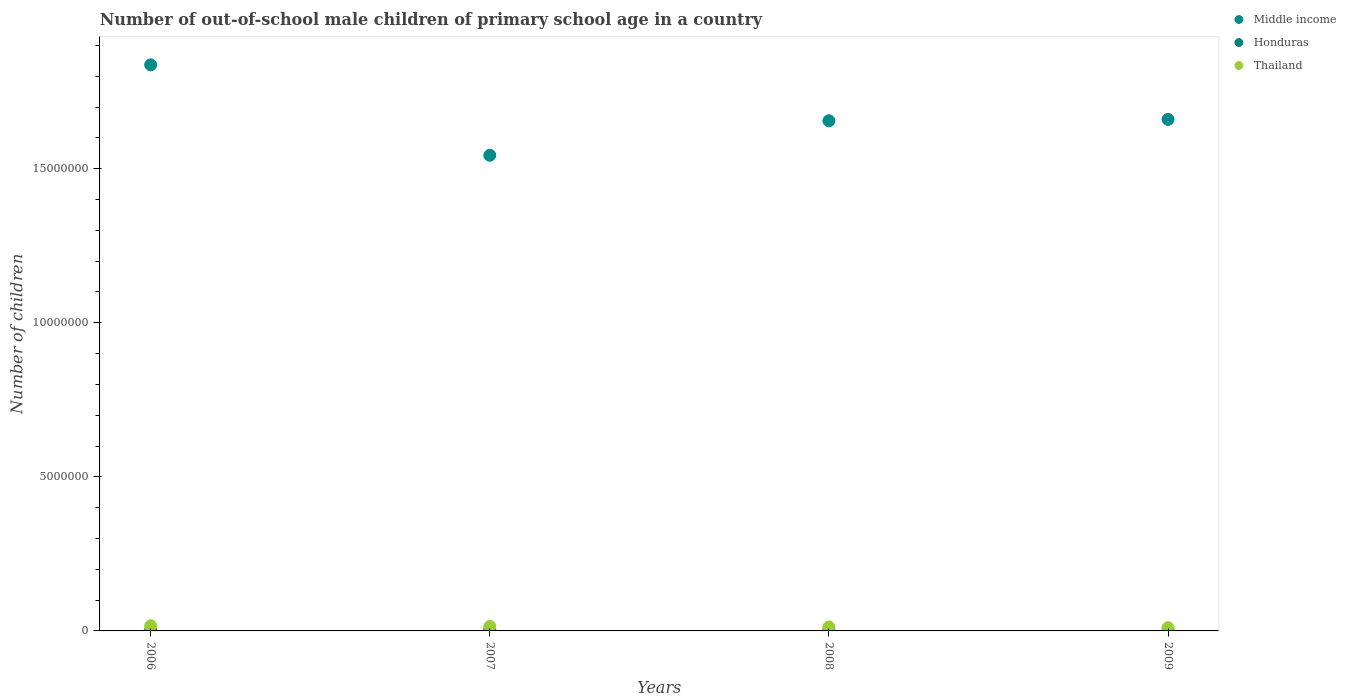What is the number of out-of-school male children in Middle income in 2006?
Give a very brief answer. 1.84e+07. Across all years, what is the maximum number of out-of-school male children in Honduras?
Keep it short and to the point. 4.40e+04. Across all years, what is the minimum number of out-of-school male children in Honduras?
Provide a short and direct response. 2.52e+04. In which year was the number of out-of-school male children in Honduras minimum?
Keep it short and to the point. 2009. What is the total number of out-of-school male children in Middle income in the graph?
Your response must be concise. 6.70e+07. What is the difference between the number of out-of-school male children in Middle income in 2008 and that in 2009?
Provide a succinct answer. -4.42e+04. What is the difference between the number of out-of-school male children in Honduras in 2006 and the number of out-of-school male children in Middle income in 2007?
Give a very brief answer. -1.54e+07. What is the average number of out-of-school male children in Honduras per year?
Keep it short and to the point. 3.06e+04. In the year 2008, what is the difference between the number of out-of-school male children in Honduras and number of out-of-school male children in Thailand?
Your answer should be compact. -1.01e+05. What is the ratio of the number of out-of-school male children in Middle income in 2006 to that in 2007?
Your answer should be compact. 1.19. Is the difference between the number of out-of-school male children in Honduras in 2007 and 2008 greater than the difference between the number of out-of-school male children in Thailand in 2007 and 2008?
Ensure brevity in your answer.  No. What is the difference between the highest and the second highest number of out-of-school male children in Honduras?
Ensure brevity in your answer.  1.67e+04. What is the difference between the highest and the lowest number of out-of-school male children in Honduras?
Your answer should be very brief. 1.87e+04. In how many years, is the number of out-of-school male children in Thailand greater than the average number of out-of-school male children in Thailand taken over all years?
Provide a short and direct response. 2. Is the sum of the number of out-of-school male children in Middle income in 2006 and 2009 greater than the maximum number of out-of-school male children in Thailand across all years?
Make the answer very short. Yes. Is the number of out-of-school male children in Honduras strictly greater than the number of out-of-school male children in Thailand over the years?
Keep it short and to the point. No. How many dotlines are there?
Give a very brief answer. 3. Does the graph contain any zero values?
Give a very brief answer. No. Does the graph contain grids?
Give a very brief answer. No. Where does the legend appear in the graph?
Your answer should be compact. Top right. How many legend labels are there?
Your answer should be very brief. 3. What is the title of the graph?
Ensure brevity in your answer.  Number of out-of-school male children of primary school age in a country. Does "Madagascar" appear as one of the legend labels in the graph?
Offer a very short reply. No. What is the label or title of the X-axis?
Give a very brief answer. Years. What is the label or title of the Y-axis?
Offer a very short reply. Number of children. What is the Number of children of Middle income in 2006?
Keep it short and to the point. 1.84e+07. What is the Number of children in Honduras in 2006?
Keep it short and to the point. 2.59e+04. What is the Number of children of Thailand in 2006?
Your answer should be compact. 1.67e+05. What is the Number of children in Middle income in 2007?
Provide a succinct answer. 1.54e+07. What is the Number of children in Honduras in 2007?
Keep it short and to the point. 4.40e+04. What is the Number of children in Thailand in 2007?
Your answer should be very brief. 1.47e+05. What is the Number of children in Middle income in 2008?
Make the answer very short. 1.66e+07. What is the Number of children in Honduras in 2008?
Your response must be concise. 2.73e+04. What is the Number of children in Thailand in 2008?
Your response must be concise. 1.29e+05. What is the Number of children in Middle income in 2009?
Provide a succinct answer. 1.66e+07. What is the Number of children of Honduras in 2009?
Provide a short and direct response. 2.52e+04. What is the Number of children of Thailand in 2009?
Your answer should be compact. 1.07e+05. Across all years, what is the maximum Number of children in Middle income?
Ensure brevity in your answer.  1.84e+07. Across all years, what is the maximum Number of children of Honduras?
Make the answer very short. 4.40e+04. Across all years, what is the maximum Number of children of Thailand?
Provide a short and direct response. 1.67e+05. Across all years, what is the minimum Number of children of Middle income?
Provide a short and direct response. 1.54e+07. Across all years, what is the minimum Number of children in Honduras?
Offer a terse response. 2.52e+04. Across all years, what is the minimum Number of children in Thailand?
Your response must be concise. 1.07e+05. What is the total Number of children in Middle income in the graph?
Offer a very short reply. 6.70e+07. What is the total Number of children of Honduras in the graph?
Your response must be concise. 1.22e+05. What is the total Number of children in Thailand in the graph?
Keep it short and to the point. 5.50e+05. What is the difference between the Number of children in Middle income in 2006 and that in 2007?
Make the answer very short. 2.94e+06. What is the difference between the Number of children in Honduras in 2006 and that in 2007?
Provide a succinct answer. -1.81e+04. What is the difference between the Number of children of Thailand in 2006 and that in 2007?
Keep it short and to the point. 2.01e+04. What is the difference between the Number of children in Middle income in 2006 and that in 2008?
Provide a succinct answer. 1.82e+06. What is the difference between the Number of children of Honduras in 2006 and that in 2008?
Provide a succinct answer. -1472. What is the difference between the Number of children of Thailand in 2006 and that in 2008?
Provide a succinct answer. 3.86e+04. What is the difference between the Number of children of Middle income in 2006 and that in 2009?
Give a very brief answer. 1.77e+06. What is the difference between the Number of children in Honduras in 2006 and that in 2009?
Provide a short and direct response. 610. What is the difference between the Number of children of Thailand in 2006 and that in 2009?
Your response must be concise. 6.07e+04. What is the difference between the Number of children of Middle income in 2007 and that in 2008?
Your answer should be compact. -1.12e+06. What is the difference between the Number of children in Honduras in 2007 and that in 2008?
Offer a very short reply. 1.67e+04. What is the difference between the Number of children in Thailand in 2007 and that in 2008?
Offer a very short reply. 1.85e+04. What is the difference between the Number of children in Middle income in 2007 and that in 2009?
Your answer should be compact. -1.16e+06. What is the difference between the Number of children in Honduras in 2007 and that in 2009?
Provide a succinct answer. 1.87e+04. What is the difference between the Number of children in Thailand in 2007 and that in 2009?
Your answer should be compact. 4.06e+04. What is the difference between the Number of children of Middle income in 2008 and that in 2009?
Give a very brief answer. -4.42e+04. What is the difference between the Number of children of Honduras in 2008 and that in 2009?
Keep it short and to the point. 2082. What is the difference between the Number of children in Thailand in 2008 and that in 2009?
Give a very brief answer. 2.21e+04. What is the difference between the Number of children in Middle income in 2006 and the Number of children in Honduras in 2007?
Your response must be concise. 1.83e+07. What is the difference between the Number of children of Middle income in 2006 and the Number of children of Thailand in 2007?
Your answer should be compact. 1.82e+07. What is the difference between the Number of children of Honduras in 2006 and the Number of children of Thailand in 2007?
Your answer should be very brief. -1.21e+05. What is the difference between the Number of children in Middle income in 2006 and the Number of children in Honduras in 2008?
Keep it short and to the point. 1.83e+07. What is the difference between the Number of children in Middle income in 2006 and the Number of children in Thailand in 2008?
Ensure brevity in your answer.  1.82e+07. What is the difference between the Number of children in Honduras in 2006 and the Number of children in Thailand in 2008?
Keep it short and to the point. -1.03e+05. What is the difference between the Number of children of Middle income in 2006 and the Number of children of Honduras in 2009?
Give a very brief answer. 1.83e+07. What is the difference between the Number of children in Middle income in 2006 and the Number of children in Thailand in 2009?
Provide a short and direct response. 1.83e+07. What is the difference between the Number of children in Honduras in 2006 and the Number of children in Thailand in 2009?
Provide a succinct answer. -8.07e+04. What is the difference between the Number of children in Middle income in 2007 and the Number of children in Honduras in 2008?
Provide a short and direct response. 1.54e+07. What is the difference between the Number of children in Middle income in 2007 and the Number of children in Thailand in 2008?
Your answer should be compact. 1.53e+07. What is the difference between the Number of children of Honduras in 2007 and the Number of children of Thailand in 2008?
Offer a terse response. -8.46e+04. What is the difference between the Number of children in Middle income in 2007 and the Number of children in Honduras in 2009?
Your answer should be very brief. 1.54e+07. What is the difference between the Number of children of Middle income in 2007 and the Number of children of Thailand in 2009?
Keep it short and to the point. 1.53e+07. What is the difference between the Number of children in Honduras in 2007 and the Number of children in Thailand in 2009?
Your response must be concise. -6.26e+04. What is the difference between the Number of children in Middle income in 2008 and the Number of children in Honduras in 2009?
Provide a succinct answer. 1.65e+07. What is the difference between the Number of children of Middle income in 2008 and the Number of children of Thailand in 2009?
Offer a very short reply. 1.65e+07. What is the difference between the Number of children in Honduras in 2008 and the Number of children in Thailand in 2009?
Offer a terse response. -7.92e+04. What is the average Number of children in Middle income per year?
Keep it short and to the point. 1.67e+07. What is the average Number of children in Honduras per year?
Offer a very short reply. 3.06e+04. What is the average Number of children in Thailand per year?
Provide a short and direct response. 1.37e+05. In the year 2006, what is the difference between the Number of children of Middle income and Number of children of Honduras?
Provide a short and direct response. 1.83e+07. In the year 2006, what is the difference between the Number of children of Middle income and Number of children of Thailand?
Your answer should be very brief. 1.82e+07. In the year 2006, what is the difference between the Number of children in Honduras and Number of children in Thailand?
Your answer should be very brief. -1.41e+05. In the year 2007, what is the difference between the Number of children in Middle income and Number of children in Honduras?
Make the answer very short. 1.54e+07. In the year 2007, what is the difference between the Number of children in Middle income and Number of children in Thailand?
Provide a succinct answer. 1.53e+07. In the year 2007, what is the difference between the Number of children in Honduras and Number of children in Thailand?
Provide a succinct answer. -1.03e+05. In the year 2008, what is the difference between the Number of children of Middle income and Number of children of Honduras?
Keep it short and to the point. 1.65e+07. In the year 2008, what is the difference between the Number of children of Middle income and Number of children of Thailand?
Provide a succinct answer. 1.64e+07. In the year 2008, what is the difference between the Number of children of Honduras and Number of children of Thailand?
Your answer should be very brief. -1.01e+05. In the year 2009, what is the difference between the Number of children of Middle income and Number of children of Honduras?
Offer a terse response. 1.66e+07. In the year 2009, what is the difference between the Number of children of Middle income and Number of children of Thailand?
Provide a short and direct response. 1.65e+07. In the year 2009, what is the difference between the Number of children of Honduras and Number of children of Thailand?
Your answer should be very brief. -8.13e+04. What is the ratio of the Number of children of Middle income in 2006 to that in 2007?
Your response must be concise. 1.19. What is the ratio of the Number of children in Honduras in 2006 to that in 2007?
Offer a very short reply. 0.59. What is the ratio of the Number of children of Thailand in 2006 to that in 2007?
Provide a short and direct response. 1.14. What is the ratio of the Number of children in Middle income in 2006 to that in 2008?
Keep it short and to the point. 1.11. What is the ratio of the Number of children in Honduras in 2006 to that in 2008?
Offer a very short reply. 0.95. What is the ratio of the Number of children of Thailand in 2006 to that in 2008?
Your answer should be very brief. 1.3. What is the ratio of the Number of children in Middle income in 2006 to that in 2009?
Your answer should be compact. 1.11. What is the ratio of the Number of children in Honduras in 2006 to that in 2009?
Your response must be concise. 1.02. What is the ratio of the Number of children of Thailand in 2006 to that in 2009?
Offer a very short reply. 1.57. What is the ratio of the Number of children in Middle income in 2007 to that in 2008?
Your response must be concise. 0.93. What is the ratio of the Number of children in Honduras in 2007 to that in 2008?
Your answer should be very brief. 1.61. What is the ratio of the Number of children in Thailand in 2007 to that in 2008?
Provide a succinct answer. 1.14. What is the ratio of the Number of children of Middle income in 2007 to that in 2009?
Offer a terse response. 0.93. What is the ratio of the Number of children of Honduras in 2007 to that in 2009?
Provide a short and direct response. 1.74. What is the ratio of the Number of children in Thailand in 2007 to that in 2009?
Ensure brevity in your answer.  1.38. What is the ratio of the Number of children of Middle income in 2008 to that in 2009?
Provide a succinct answer. 1. What is the ratio of the Number of children of Honduras in 2008 to that in 2009?
Give a very brief answer. 1.08. What is the ratio of the Number of children in Thailand in 2008 to that in 2009?
Ensure brevity in your answer.  1.21. What is the difference between the highest and the second highest Number of children of Middle income?
Ensure brevity in your answer.  1.77e+06. What is the difference between the highest and the second highest Number of children of Honduras?
Give a very brief answer. 1.67e+04. What is the difference between the highest and the second highest Number of children of Thailand?
Your answer should be very brief. 2.01e+04. What is the difference between the highest and the lowest Number of children of Middle income?
Give a very brief answer. 2.94e+06. What is the difference between the highest and the lowest Number of children of Honduras?
Offer a terse response. 1.87e+04. What is the difference between the highest and the lowest Number of children of Thailand?
Provide a succinct answer. 6.07e+04. 